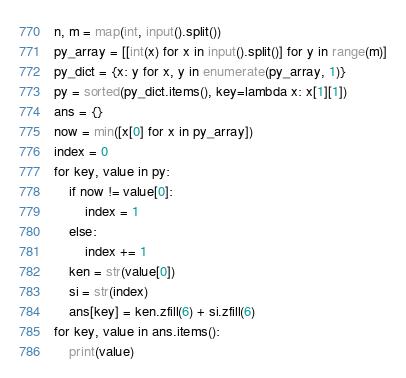Convert code to text. <code><loc_0><loc_0><loc_500><loc_500><_Python_>n, m = map(int, input().split())
py_array = [[int(x) for x in input().split()] for y in range(m)]
py_dict = {x: y for x, y in enumerate(py_array, 1)}
py = sorted(py_dict.items(), key=lambda x: x[1][1])
ans = {}
now = min([x[0] for x in py_array])
index = 0
for key, value in py:
    if now != value[0]:
        index = 1
    else:
        index += 1
    ken = str(value[0])
    si = str(index)
    ans[key] = ken.zfill(6) + si.zfill(6)
for key, value in ans.items():
    print(value)
</code> 